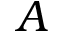<formula> <loc_0><loc_0><loc_500><loc_500>A</formula> 